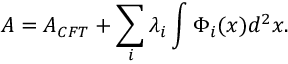<formula> <loc_0><loc_0><loc_500><loc_500>A = A _ { C F T } + \sum _ { i } \lambda _ { i } \int \Phi _ { i } ( x ) d ^ { 2 } x .</formula> 